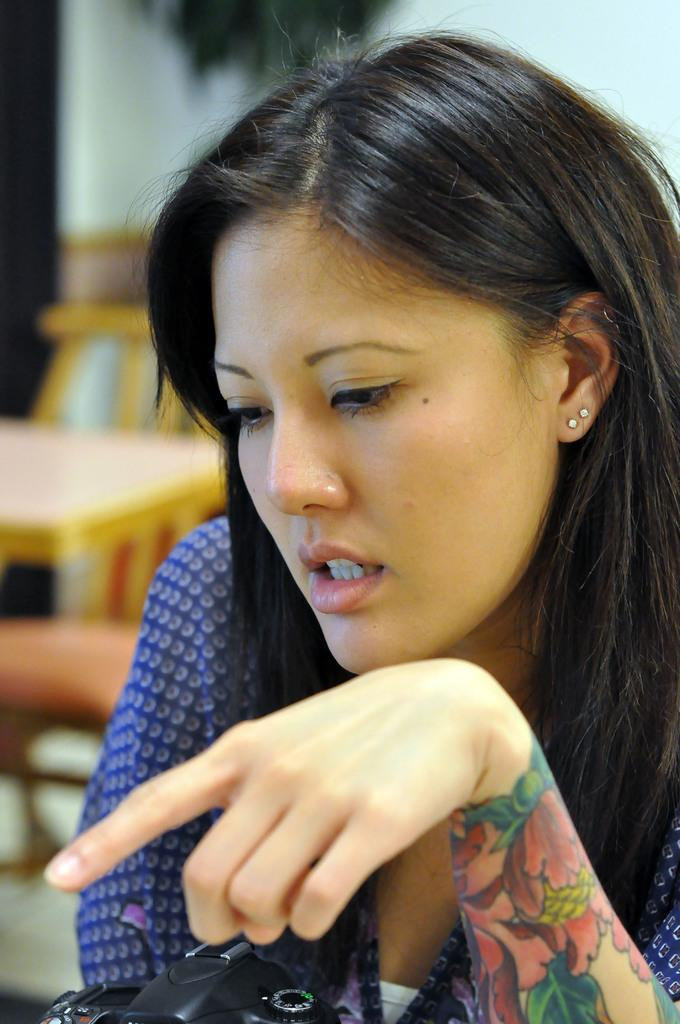Who is present in the image? There is a woman in the image. What can be seen on the woman's hand? The woman has a tattoo on her hand. What object is visible in the image? There is a camera in the image. What type of furniture can be seen in the background of the image? There are chairs in the background of the image. What is the background setting of the image? There is a table and a wall in the background of the image. What type of cheese is being used to cover the curtain in the image? There is no cheese or curtain present in the image. 